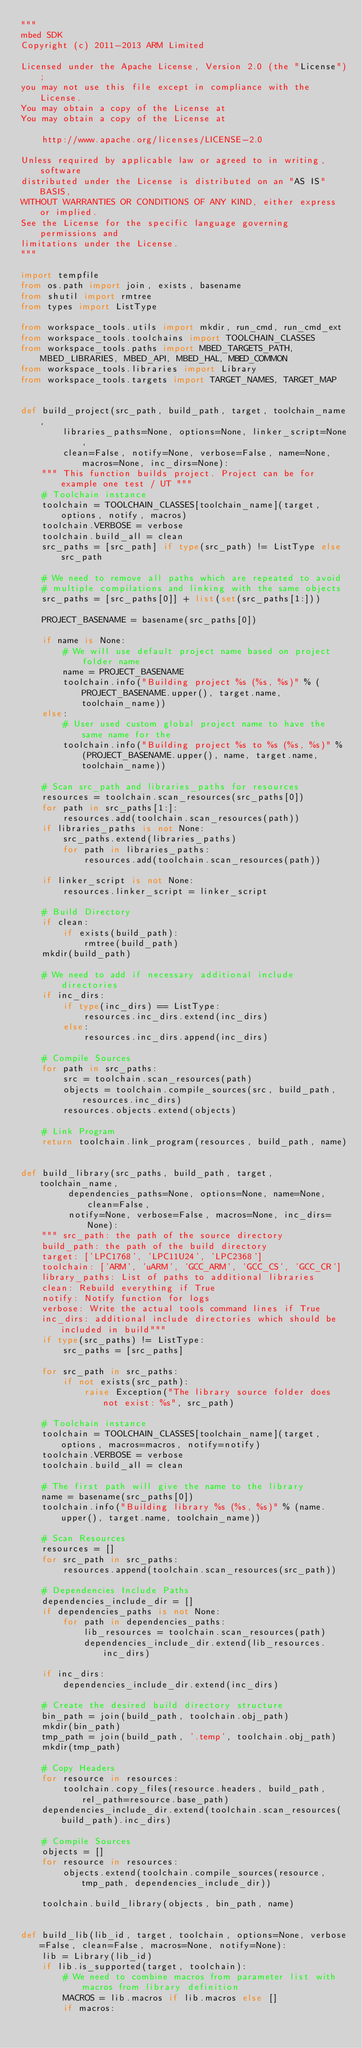Convert code to text. <code><loc_0><loc_0><loc_500><loc_500><_Python_>"""
mbed SDK
Copyright (c) 2011-2013 ARM Limited

Licensed under the Apache License, Version 2.0 (the "License");
you may not use this file except in compliance with the License.
You may obtain a copy of the License at
You may obtain a copy of the License at

    http://www.apache.org/licenses/LICENSE-2.0

Unless required by applicable law or agreed to in writing, software
distributed under the License is distributed on an "AS IS" BASIS,
WITHOUT WARRANTIES OR CONDITIONS OF ANY KIND, either express or implied.
See the License for the specific language governing permissions and
limitations under the License.
"""

import tempfile
from os.path import join, exists, basename
from shutil import rmtree
from types import ListType

from workspace_tools.utils import mkdir, run_cmd, run_cmd_ext
from workspace_tools.toolchains import TOOLCHAIN_CLASSES
from workspace_tools.paths import MBED_TARGETS_PATH, MBED_LIBRARIES, MBED_API, MBED_HAL, MBED_COMMON
from workspace_tools.libraries import Library
from workspace_tools.targets import TARGET_NAMES, TARGET_MAP


def build_project(src_path, build_path, target, toolchain_name,
        libraries_paths=None, options=None, linker_script=None,
        clean=False, notify=None, verbose=False, name=None, macros=None, inc_dirs=None):
    """ This function builds project. Project can be for example one test / UT """
    # Toolchain instance
    toolchain = TOOLCHAIN_CLASSES[toolchain_name](target, options, notify, macros)
    toolchain.VERBOSE = verbose
    toolchain.build_all = clean
    src_paths = [src_path] if type(src_path) != ListType else src_path

    # We need to remove all paths which are repeated to avoid
    # multiple compilations and linking with the same objects
    src_paths = [src_paths[0]] + list(set(src_paths[1:]))

    PROJECT_BASENAME = basename(src_paths[0])

    if name is None:
        # We will use default project name based on project folder name
        name = PROJECT_BASENAME
        toolchain.info("Building project %s (%s, %s)" % (PROJECT_BASENAME.upper(), target.name, toolchain_name))
    else:
        # User used custom global project name to have the same name for the
        toolchain.info("Building project %s to %s (%s, %s)" % (PROJECT_BASENAME.upper(), name, target.name, toolchain_name))

    # Scan src_path and libraries_paths for resources
    resources = toolchain.scan_resources(src_paths[0])
    for path in src_paths[1:]:
        resources.add(toolchain.scan_resources(path))
    if libraries_paths is not None:
        src_paths.extend(libraries_paths)
        for path in libraries_paths:
            resources.add(toolchain.scan_resources(path))

    if linker_script is not None:
        resources.linker_script = linker_script

    # Build Directory
    if clean:
        if exists(build_path):
            rmtree(build_path)
    mkdir(build_path)

    # We need to add if necessary additional include directories
    if inc_dirs:
        if type(inc_dirs) == ListType:
            resources.inc_dirs.extend(inc_dirs)
        else:
            resources.inc_dirs.append(inc_dirs)

    # Compile Sources
    for path in src_paths:
        src = toolchain.scan_resources(path)
        objects = toolchain.compile_sources(src, build_path, resources.inc_dirs)
        resources.objects.extend(objects)

    # Link Program
    return toolchain.link_program(resources, build_path, name)


def build_library(src_paths, build_path, target, toolchain_name,
         dependencies_paths=None, options=None, name=None, clean=False,
         notify=None, verbose=False, macros=None, inc_dirs=None):
    """ src_path: the path of the source directory
    build_path: the path of the build directory
    target: ['LPC1768', 'LPC11U24', 'LPC2368']
    toolchain: ['ARM', 'uARM', 'GCC_ARM', 'GCC_CS', 'GCC_CR']
    library_paths: List of paths to additional libraries
    clean: Rebuild everything if True
    notify: Notify function for logs
    verbose: Write the actual tools command lines if True
    inc_dirs: additional include directories which should be included in build"""
    if type(src_paths) != ListType:
        src_paths = [src_paths]

    for src_path in src_paths:
        if not exists(src_path):
            raise Exception("The library source folder does not exist: %s", src_path)

    # Toolchain instance
    toolchain = TOOLCHAIN_CLASSES[toolchain_name](target, options, macros=macros, notify=notify)
    toolchain.VERBOSE = verbose
    toolchain.build_all = clean

    # The first path will give the name to the library
    name = basename(src_paths[0])
    toolchain.info("Building library %s (%s, %s)" % (name.upper(), target.name, toolchain_name))

    # Scan Resources
    resources = []
    for src_path in src_paths:
        resources.append(toolchain.scan_resources(src_path))

    # Dependencies Include Paths
    dependencies_include_dir = []
    if dependencies_paths is not None:
        for path in dependencies_paths:
            lib_resources = toolchain.scan_resources(path)
            dependencies_include_dir.extend(lib_resources.inc_dirs)

    if inc_dirs:
        dependencies_include_dir.extend(inc_dirs)

    # Create the desired build directory structure
    bin_path = join(build_path, toolchain.obj_path)
    mkdir(bin_path)
    tmp_path = join(build_path, '.temp', toolchain.obj_path)
    mkdir(tmp_path)

    # Copy Headers
    for resource in resources:
        toolchain.copy_files(resource.headers, build_path, rel_path=resource.base_path)
    dependencies_include_dir.extend(toolchain.scan_resources(build_path).inc_dirs)

    # Compile Sources
    objects = []
    for resource in resources:
        objects.extend(toolchain.compile_sources(resource, tmp_path, dependencies_include_dir))

    toolchain.build_library(objects, bin_path, name)


def build_lib(lib_id, target, toolchain, options=None, verbose=False, clean=False, macros=None, notify=None):
    lib = Library(lib_id)
    if lib.is_supported(target, toolchain):
        # We need to combine macros from parameter list with macros from library definition
        MACROS = lib.macros if lib.macros else []
        if macros:</code> 